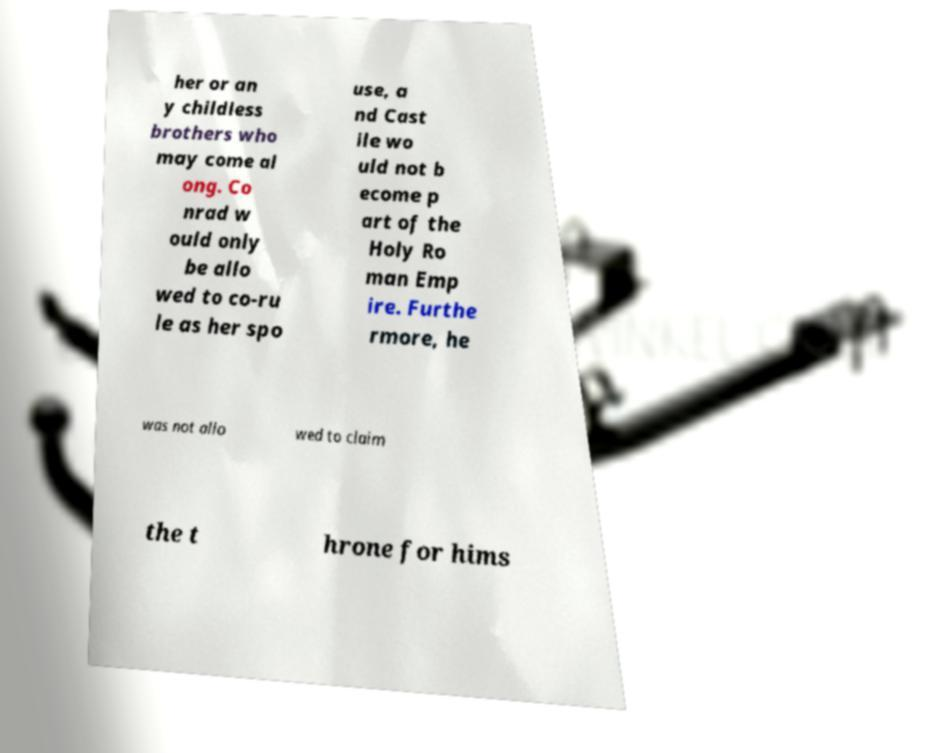Please read and relay the text visible in this image. What does it say? her or an y childless brothers who may come al ong. Co nrad w ould only be allo wed to co-ru le as her spo use, a nd Cast ile wo uld not b ecome p art of the Holy Ro man Emp ire. Furthe rmore, he was not allo wed to claim the t hrone for hims 